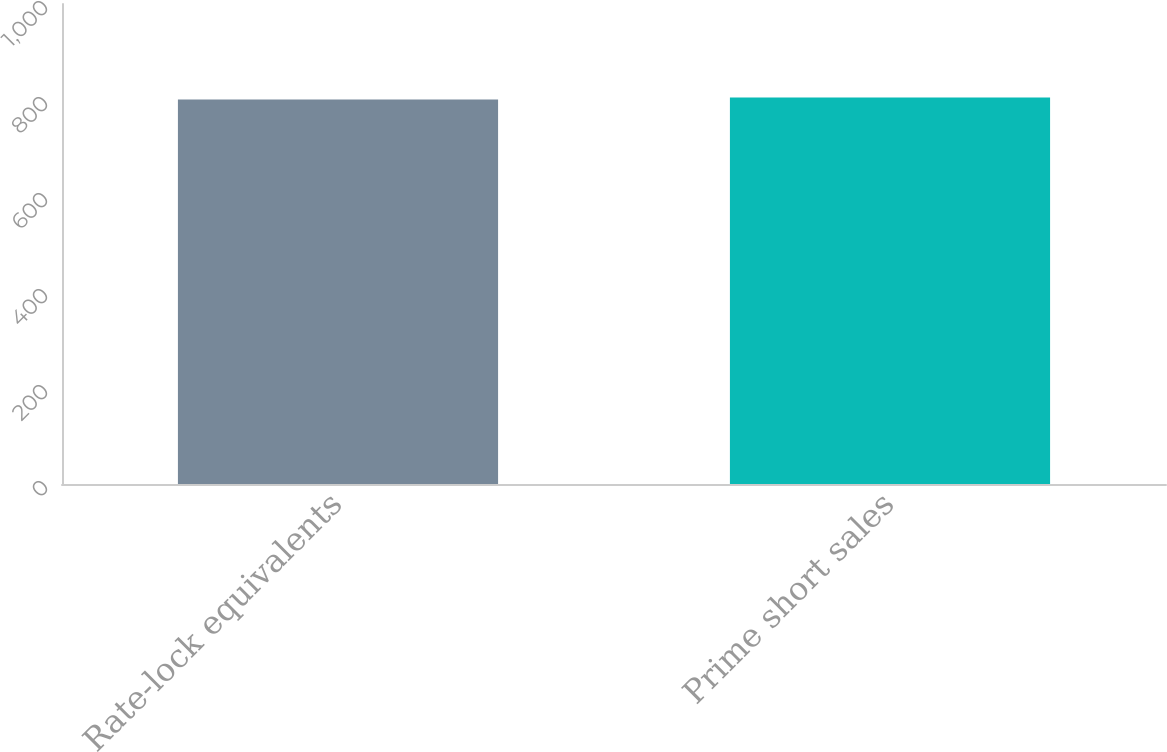Convert chart to OTSL. <chart><loc_0><loc_0><loc_500><loc_500><bar_chart><fcel>Rate-lock equivalents<fcel>Prime short sales<nl><fcel>801<fcel>805<nl></chart> 